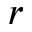<formula> <loc_0><loc_0><loc_500><loc_500>r</formula> 